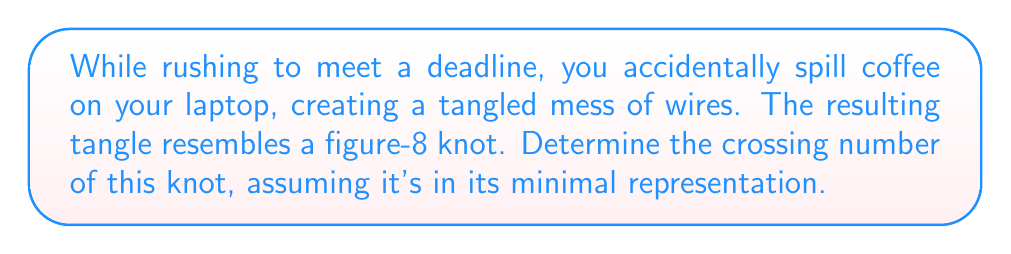Provide a solution to this math problem. Let's approach this step-by-step:

1) The figure-8 knot, also known as the $4_1$ knot in Alexander-Briggs notation, is one of the simplest non-trivial knots.

2) To find the crossing number, we need to consider the minimal diagram of the knot. The minimal diagram is the representation with the least number of crossings.

3) The standard diagram of a figure-8 knot looks like this:

   [asy]
   import geometry;

   path p = (0,0)..(1,1)..(2,0)..(1,-1)..cycle;
   path q = (2,0)..(3,1)..(4,0)..(3,-1)..cycle;

   draw(p);
   draw(q);

   dot((1,0));
   dot((3,0));
   dot((2,1));
   dot((2,-1));
   [/asy]

4) Counting the crossings in this diagram, we can see that there are 4 distinct crossings.

5) It's important to note that this is indeed the minimal representation of the figure-8 knot. No diagram of this knot can be drawn with fewer than 4 crossings.

6) The crossing number of a knot is defined as the minimum number of crossings in any diagram of the knot.

7) Therefore, the crossing number of the figure-8 knot is 4.

This result is well-known in knot theory and has been rigorously proven.
Answer: 4 